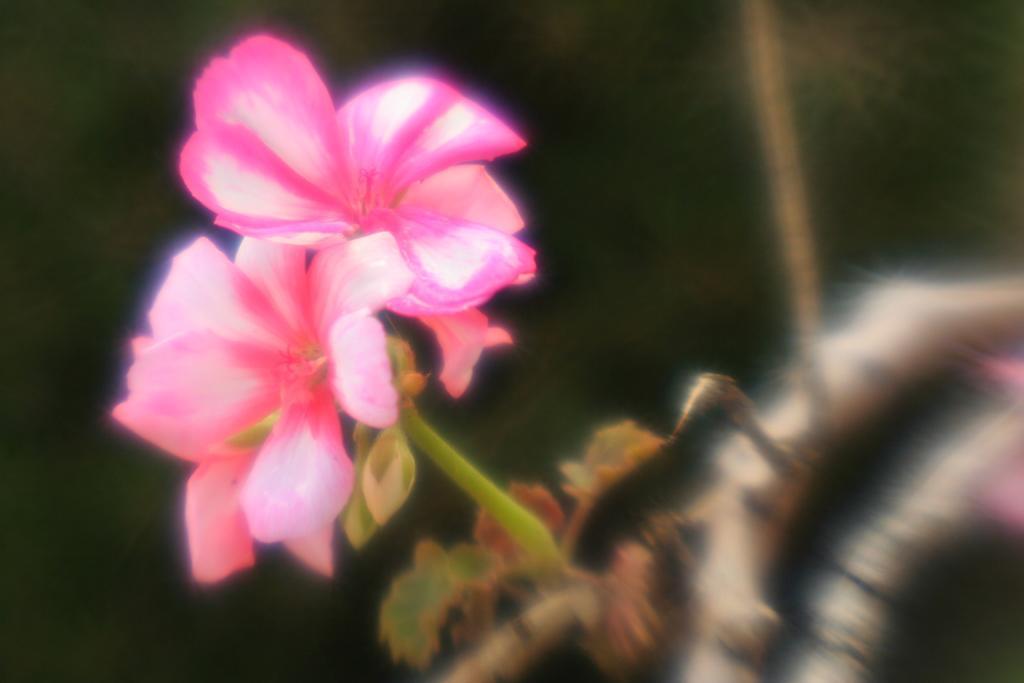Could you give a brief overview of what you see in this image? In this image, I can see the flowers to a stem. These flowers are pink in color. The background looks blurry. On the right side of the image, these look like the branches. I think this picture looks slightly blurred. 